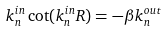<formula> <loc_0><loc_0><loc_500><loc_500>k _ { n } ^ { i n } \cot ( k _ { n } ^ { i n } R ) = - \beta k _ { n } ^ { o u t }</formula> 